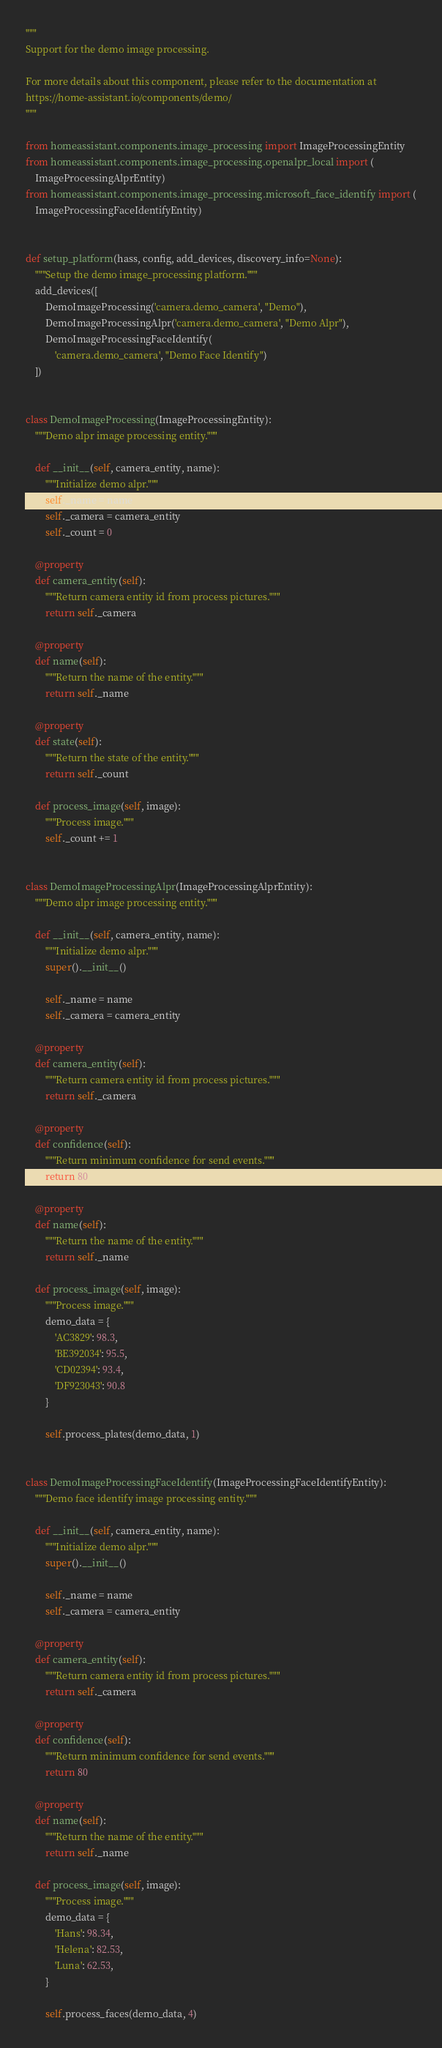Convert code to text. <code><loc_0><loc_0><loc_500><loc_500><_Python_>"""
Support for the demo image processing.

For more details about this component, please refer to the documentation at
https://home-assistant.io/components/demo/
"""

from homeassistant.components.image_processing import ImageProcessingEntity
from homeassistant.components.image_processing.openalpr_local import (
    ImageProcessingAlprEntity)
from homeassistant.components.image_processing.microsoft_face_identify import (
    ImageProcessingFaceIdentifyEntity)


def setup_platform(hass, config, add_devices, discovery_info=None):
    """Setup the demo image_processing platform."""
    add_devices([
        DemoImageProcessing('camera.demo_camera', "Demo"),
        DemoImageProcessingAlpr('camera.demo_camera', "Demo Alpr"),
        DemoImageProcessingFaceIdentify(
            'camera.demo_camera', "Demo Face Identify")
    ])


class DemoImageProcessing(ImageProcessingEntity):
    """Demo alpr image processing entity."""

    def __init__(self, camera_entity, name):
        """Initialize demo alpr."""
        self._name = name
        self._camera = camera_entity
        self._count = 0

    @property
    def camera_entity(self):
        """Return camera entity id from process pictures."""
        return self._camera

    @property
    def name(self):
        """Return the name of the entity."""
        return self._name

    @property
    def state(self):
        """Return the state of the entity."""
        return self._count

    def process_image(self, image):
        """Process image."""
        self._count += 1


class DemoImageProcessingAlpr(ImageProcessingAlprEntity):
    """Demo alpr image processing entity."""

    def __init__(self, camera_entity, name):
        """Initialize demo alpr."""
        super().__init__()

        self._name = name
        self._camera = camera_entity

    @property
    def camera_entity(self):
        """Return camera entity id from process pictures."""
        return self._camera

    @property
    def confidence(self):
        """Return minimum confidence for send events."""
        return 80

    @property
    def name(self):
        """Return the name of the entity."""
        return self._name

    def process_image(self, image):
        """Process image."""
        demo_data = {
            'AC3829': 98.3,
            'BE392034': 95.5,
            'CD02394': 93.4,
            'DF923043': 90.8
        }

        self.process_plates(demo_data, 1)


class DemoImageProcessingFaceIdentify(ImageProcessingFaceIdentifyEntity):
    """Demo face identify image processing entity."""

    def __init__(self, camera_entity, name):
        """Initialize demo alpr."""
        super().__init__()

        self._name = name
        self._camera = camera_entity

    @property
    def camera_entity(self):
        """Return camera entity id from process pictures."""
        return self._camera

    @property
    def confidence(self):
        """Return minimum confidence for send events."""
        return 80

    @property
    def name(self):
        """Return the name of the entity."""
        return self._name

    def process_image(self, image):
        """Process image."""
        demo_data = {
            'Hans': 98.34,
            'Helena': 82.53,
            'Luna': 62.53,
        }

        self.process_faces(demo_data, 4)
</code> 